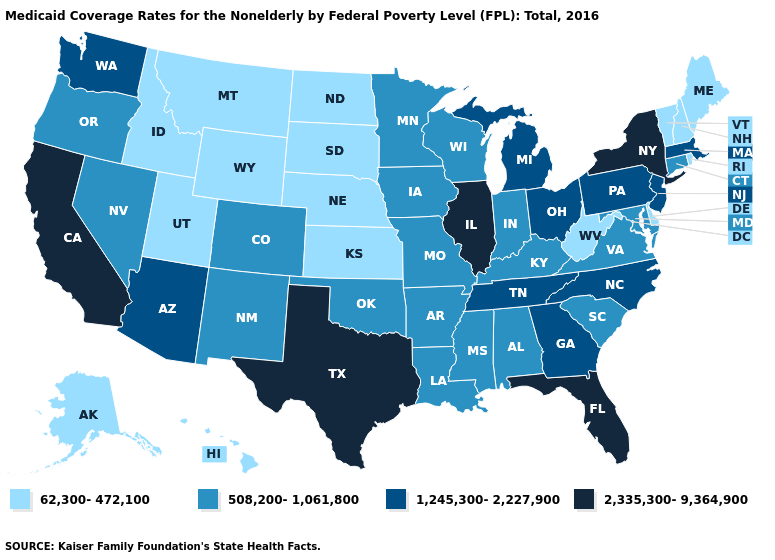Name the states that have a value in the range 508,200-1,061,800?
Quick response, please. Alabama, Arkansas, Colorado, Connecticut, Indiana, Iowa, Kentucky, Louisiana, Maryland, Minnesota, Mississippi, Missouri, Nevada, New Mexico, Oklahoma, Oregon, South Carolina, Virginia, Wisconsin. What is the highest value in the South ?
Give a very brief answer. 2,335,300-9,364,900. What is the value of Louisiana?
Keep it brief. 508,200-1,061,800. Which states have the lowest value in the Northeast?
Write a very short answer. Maine, New Hampshire, Rhode Island, Vermont. Name the states that have a value in the range 62,300-472,100?
Short answer required. Alaska, Delaware, Hawaii, Idaho, Kansas, Maine, Montana, Nebraska, New Hampshire, North Dakota, Rhode Island, South Dakota, Utah, Vermont, West Virginia, Wyoming. Name the states that have a value in the range 508,200-1,061,800?
Keep it brief. Alabama, Arkansas, Colorado, Connecticut, Indiana, Iowa, Kentucky, Louisiana, Maryland, Minnesota, Mississippi, Missouri, Nevada, New Mexico, Oklahoma, Oregon, South Carolina, Virginia, Wisconsin. What is the highest value in the Northeast ?
Be succinct. 2,335,300-9,364,900. What is the highest value in states that border New Mexico?
Concise answer only. 2,335,300-9,364,900. Does Virginia have the highest value in the USA?
Give a very brief answer. No. Name the states that have a value in the range 508,200-1,061,800?
Write a very short answer. Alabama, Arkansas, Colorado, Connecticut, Indiana, Iowa, Kentucky, Louisiana, Maryland, Minnesota, Mississippi, Missouri, Nevada, New Mexico, Oklahoma, Oregon, South Carolina, Virginia, Wisconsin. What is the value of California?
Give a very brief answer. 2,335,300-9,364,900. What is the value of West Virginia?
Answer briefly. 62,300-472,100. Which states hav the highest value in the West?
Quick response, please. California. Among the states that border Kansas , does Oklahoma have the lowest value?
Short answer required. No. Does Oklahoma have the lowest value in the South?
Give a very brief answer. No. 